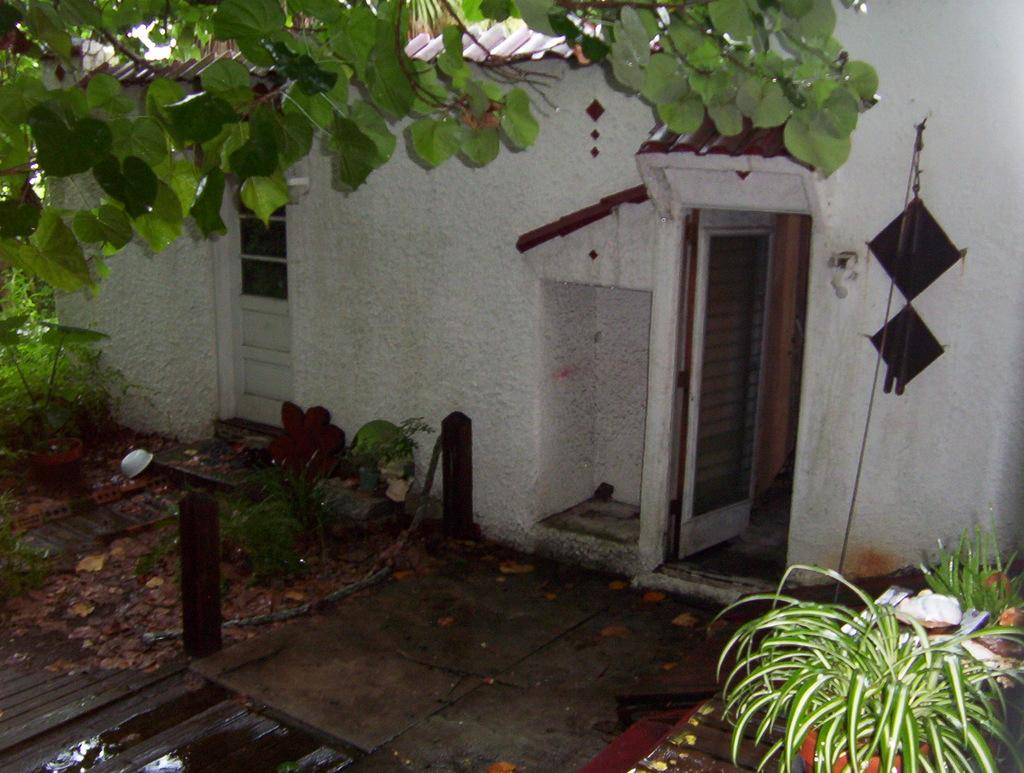What type of structure can be seen in the image? There are home doors visible in the image. What natural elements are present in the image? There are trees in the image. What type of plants are in the image? There are potted plants on the ground. What material is present on the right-hand side of the image? There are metal objects on the right-hand side of the image. Can you tell me how much cheese the expert is pushing in the image? There is no cheese or expert present in the image. What type of cheese is being pushed by the expert in the image? There is no cheese or expert present in the image, so it is not possible to determine the type of cheese being pushed. 